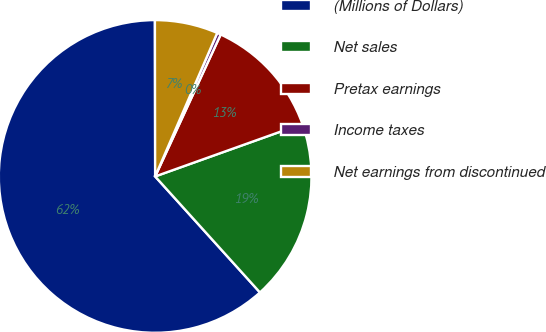Convert chart to OTSL. <chart><loc_0><loc_0><loc_500><loc_500><pie_chart><fcel>(Millions of Dollars)<fcel>Net sales<fcel>Pretax earnings<fcel>Income taxes<fcel>Net earnings from discontinued<nl><fcel>61.67%<fcel>18.77%<fcel>12.65%<fcel>0.39%<fcel>6.52%<nl></chart> 